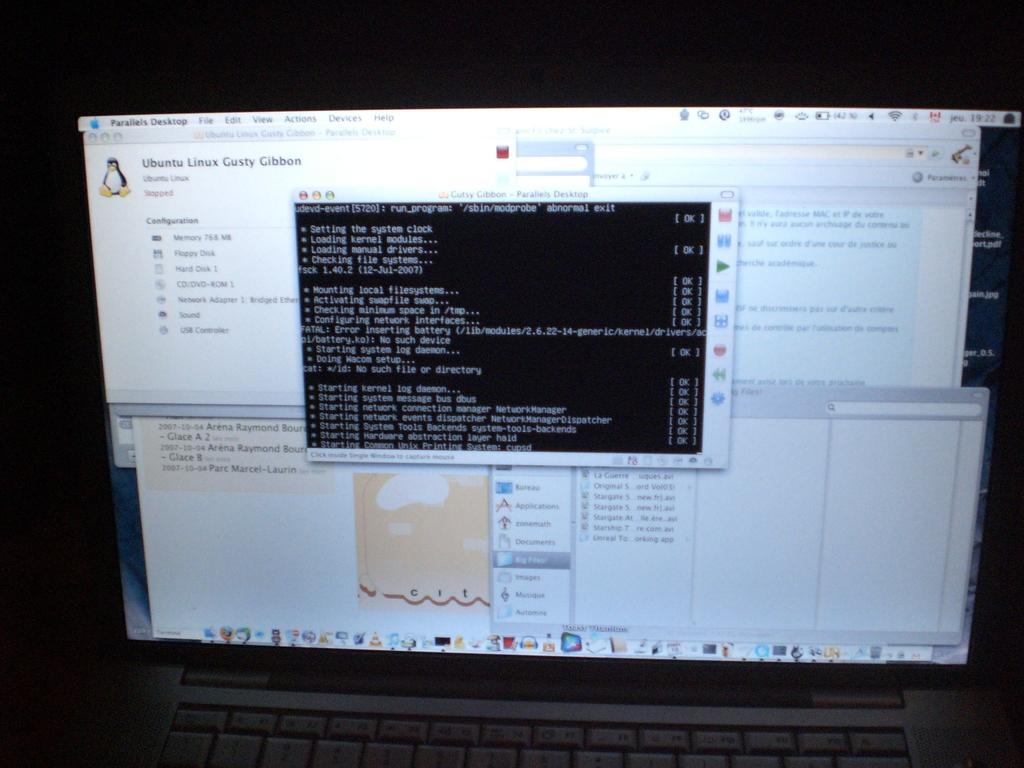Provide a one-sentence caption for the provided image. Computer screen that has a popup that says Ubuntu Linux. 